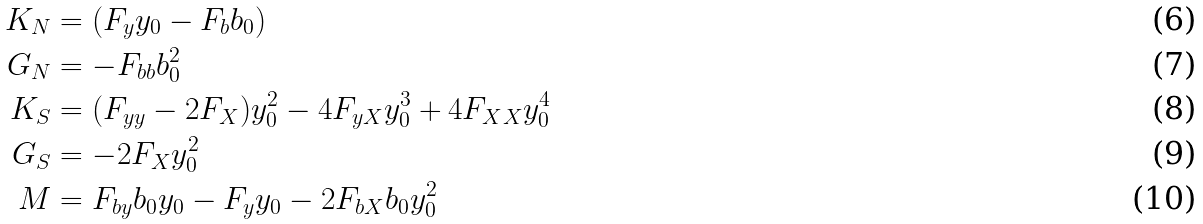Convert formula to latex. <formula><loc_0><loc_0><loc_500><loc_500>K _ { N } & = ( F _ { y } y _ { 0 } - F _ { b } b _ { 0 } ) \\ G _ { N } & = - F _ { b b } b _ { 0 } ^ { 2 } \\ K _ { S } & = ( F _ { y y } - 2 F _ { X } ) y _ { 0 } ^ { 2 } - 4 F _ { y X } y _ { 0 } ^ { 3 } + 4 F _ { X X } y _ { 0 } ^ { 4 } \\ G _ { S } & = - 2 F _ { X } y _ { 0 } ^ { 2 } \\ M & = F _ { b y } b _ { 0 } y _ { 0 } - F _ { y } y _ { 0 } - 2 F _ { b X } b _ { 0 } y _ { 0 } ^ { 2 }</formula> 